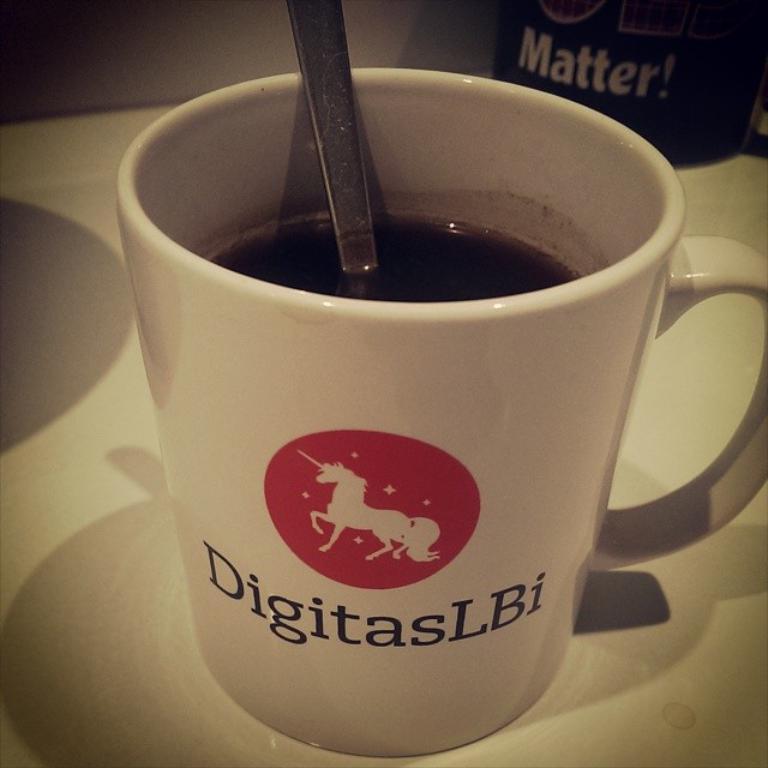What is the brand on the mug?
Provide a short and direct response. Digitaslbi. What is the first letter on the mug?
Keep it short and to the point. D. 